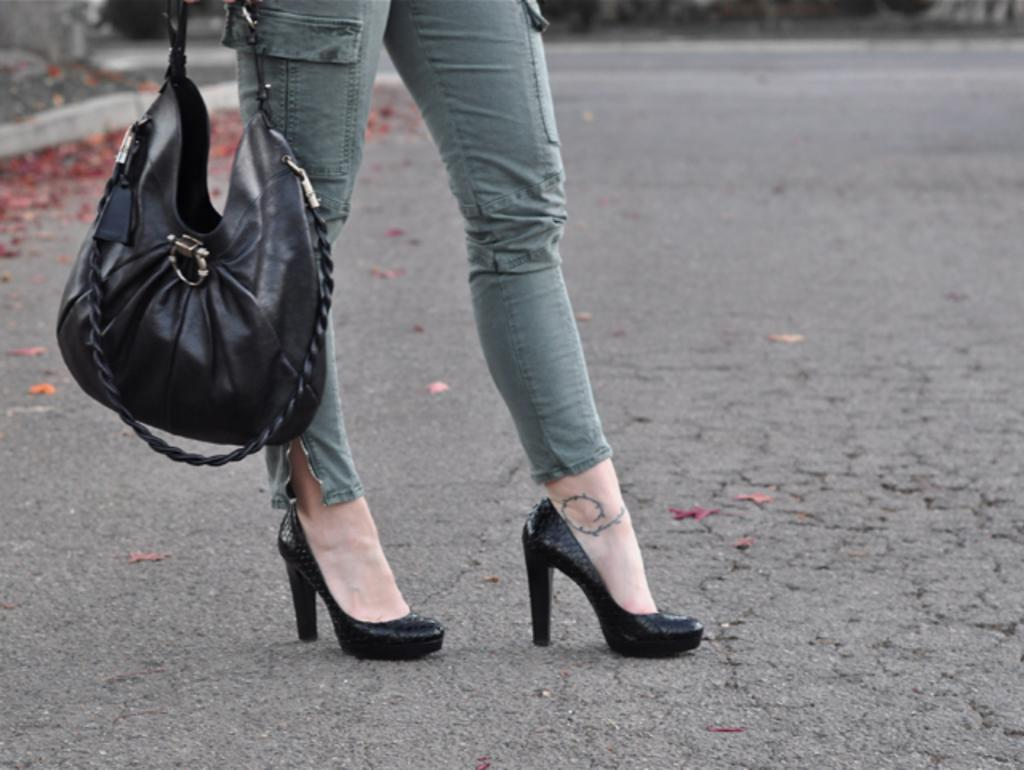What part of the lady's body is visible in the image? The image shows a lady's legs. What is the lady carrying in the image? The lady is carrying a handbag. What type of shoes is the lady wearing in the image? The lady is wearing high heels shoes. What can be seen in the background of the image? There are red flowers visible in the background of the image. Is the lady wearing a ring on her finger in the image? There is no information about a ring in the image, as it only shows the lady's legs. 